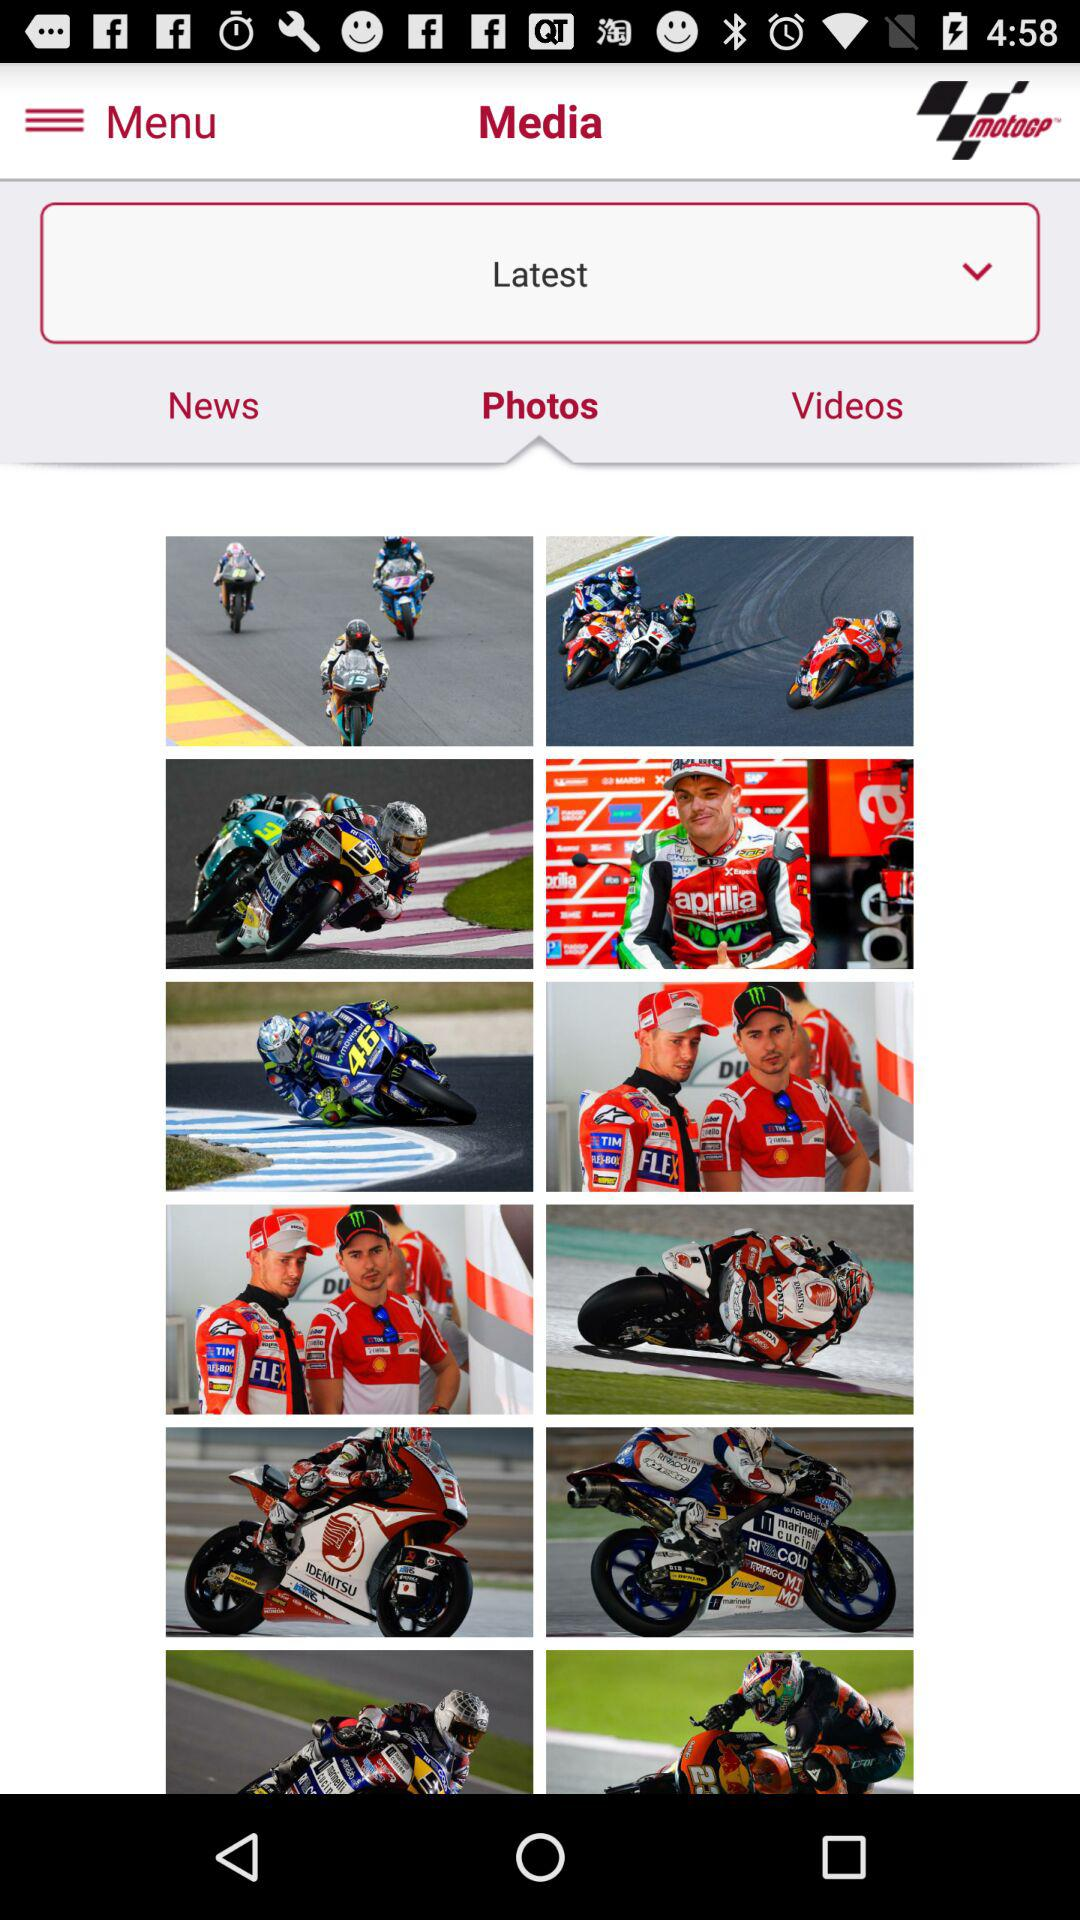Which is the selected tab? The selected tab is "Photos". 